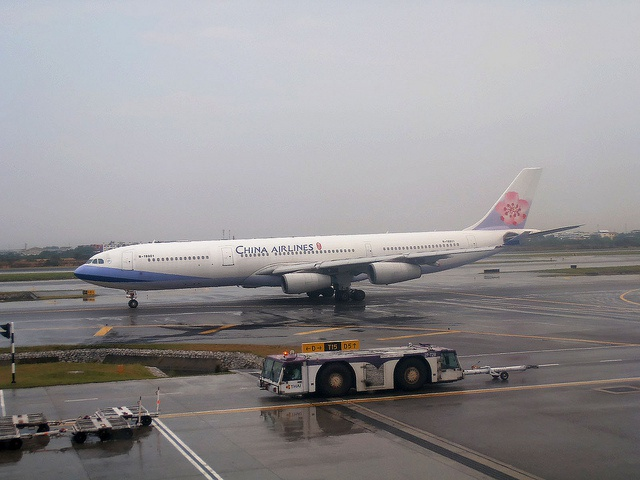Describe the objects in this image and their specific colors. I can see airplane in lightgray, darkgray, gray, and black tones, truck in lightgray, black, gray, and darkgray tones, and people in lightgray, black, and purple tones in this image. 